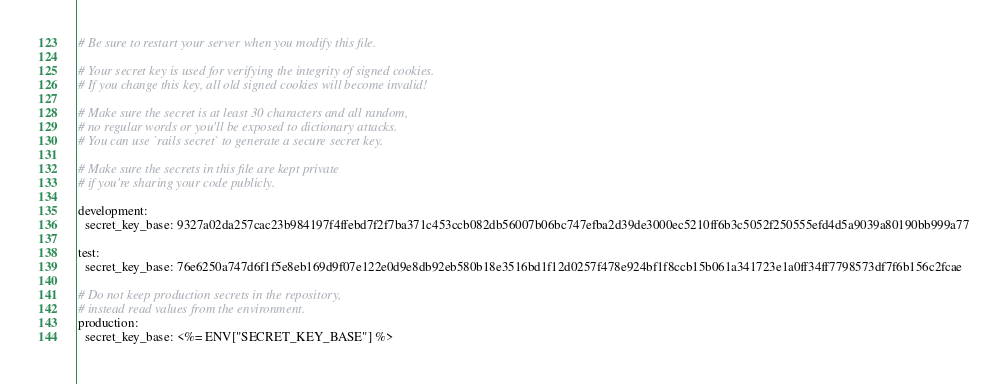Convert code to text. <code><loc_0><loc_0><loc_500><loc_500><_YAML_># Be sure to restart your server when you modify this file.

# Your secret key is used for verifying the integrity of signed cookies.
# If you change this key, all old signed cookies will become invalid!

# Make sure the secret is at least 30 characters and all random,
# no regular words or you'll be exposed to dictionary attacks.
# You can use `rails secret` to generate a secure secret key.

# Make sure the secrets in this file are kept private
# if you're sharing your code publicly.

development:
  secret_key_base: 9327a02da257cac23b984197f4ffebd7f2f7ba371c453ccb082db56007b06bc747efba2d39de3000ec5210ff6b3c5052f250555efd4d5a9039a80190bb999a77

test:
  secret_key_base: 76e6250a747d6f1f5e8eb169d9f07e122e0d9e8db92eb580b18e3516bd1f12d0257f478e924bf1f8ccb15b061a341723e1a0ff34ff7798573df7f6b156c2fcae

# Do not keep production secrets in the repository,
# instead read values from the environment.
production:
  secret_key_base: <%= ENV["SECRET_KEY_BASE"] %>
</code> 